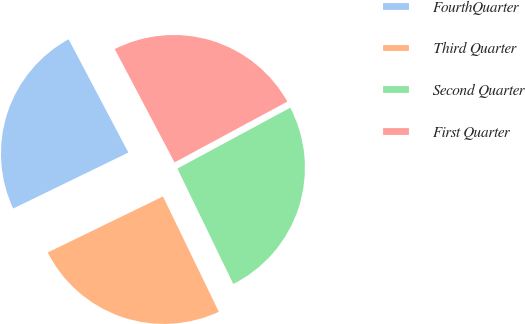Convert chart. <chart><loc_0><loc_0><loc_500><loc_500><pie_chart><fcel>FourthQuarter<fcel>Third Quarter<fcel>Second Quarter<fcel>First Quarter<nl><fcel>24.47%<fcel>24.98%<fcel>25.69%<fcel>24.86%<nl></chart> 